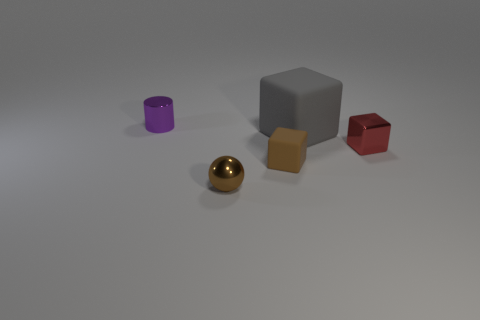What number of other things are made of the same material as the gray object?
Your answer should be very brief. 1. There is a matte thing that is behind the red metallic cube; does it have the same size as the shiny thing that is in front of the brown matte thing?
Provide a succinct answer. No. There is a brown thing that is behind the tiny brown sphere; what is its size?
Offer a terse response. Small. There is a purple cylinder that is left of the tiny thing that is in front of the brown matte block; what size is it?
Provide a succinct answer. Small. There is a red cube that is the same size as the shiny sphere; what is its material?
Ensure brevity in your answer.  Metal. Are there any gray rubber things in front of the small metallic ball?
Offer a very short reply. No. Is the number of tiny cylinders on the right side of the brown cube the same as the number of gray rubber cubes?
Keep it short and to the point. No. There is a brown metal object that is the same size as the purple shiny object; what shape is it?
Your response must be concise. Sphere. What is the purple object made of?
Ensure brevity in your answer.  Metal. There is a small metal thing that is to the left of the large gray rubber object and on the right side of the purple shiny object; what color is it?
Provide a short and direct response. Brown. 